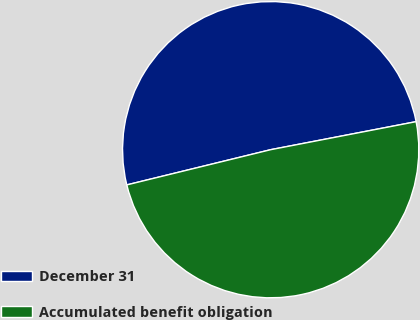<chart> <loc_0><loc_0><loc_500><loc_500><pie_chart><fcel>December 31<fcel>Accumulated benefit obligation<nl><fcel>50.79%<fcel>49.21%<nl></chart> 